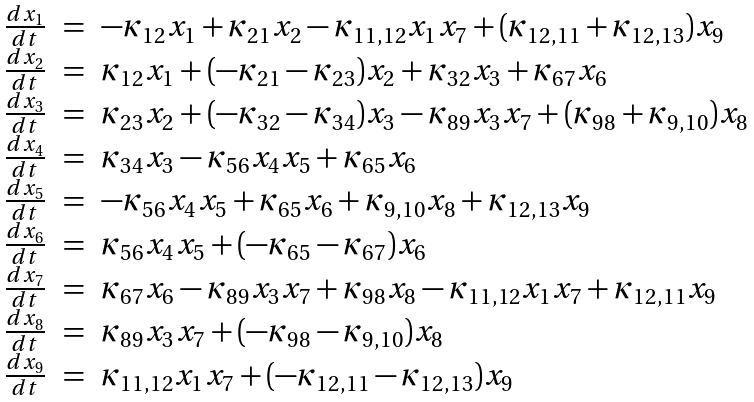Convert formula to latex. <formula><loc_0><loc_0><loc_500><loc_500>\begin{array} { c c l } \frac { d x _ { 1 } } { d t } & = & - \kappa _ { 1 2 } x _ { 1 } + \kappa _ { 2 1 } x _ { 2 } - \kappa _ { 1 1 , 1 2 } x _ { 1 } x _ { 7 } + ( \kappa _ { 1 2 , 1 1 } + \kappa _ { 1 2 , 1 3 } ) x _ { 9 } \\ \frac { d x _ { 2 } } { d t } & = & \kappa _ { 1 2 } x _ { 1 } + ( - \kappa _ { 2 1 } - \kappa _ { 2 3 } ) x _ { 2 } + \kappa _ { 3 2 } x _ { 3 } + \kappa _ { 6 7 } x _ { 6 } \\ \frac { d x _ { 3 } } { d t } & = & \kappa _ { 2 3 } x _ { 2 } + ( - \kappa _ { 3 2 } - \kappa _ { 3 4 } ) x _ { 3 } - \kappa _ { 8 9 } x _ { 3 } x _ { 7 } + ( \kappa _ { 9 8 } + \kappa _ { 9 , 1 0 } ) x _ { 8 } \\ \frac { d x _ { 4 } } { d t } & = & \kappa _ { 3 4 } x _ { 3 } - \kappa _ { 5 6 } x _ { 4 } x _ { 5 } + \kappa _ { 6 5 } x _ { 6 } \\ \frac { d x _ { 5 } } { d t } & = & - \kappa _ { 5 6 } x _ { 4 } x _ { 5 } + \kappa _ { 6 5 } x _ { 6 } + \kappa _ { 9 , 1 0 } x _ { 8 } + \kappa _ { 1 2 , 1 3 } x _ { 9 } \\ \frac { d x _ { 6 } } { d t } & = & \kappa _ { 5 6 } x _ { 4 } x _ { 5 } + ( - \kappa _ { 6 5 } - \kappa _ { 6 7 } ) x _ { 6 } \\ \frac { d x _ { 7 } } { d t } & = & \kappa _ { 6 7 } x _ { 6 } - \kappa _ { 8 9 } x _ { 3 } x _ { 7 } + \kappa _ { 9 8 } x _ { 8 } - \kappa _ { 1 1 , 1 2 } x _ { 1 } x _ { 7 } + \kappa _ { 1 2 , 1 1 } x _ { 9 } \\ \frac { d x _ { 8 } } { d t } & = & \kappa _ { 8 9 } x _ { 3 } x _ { 7 } + ( - \kappa _ { 9 8 } - \kappa _ { 9 , 1 0 } ) x _ { 8 } \\ \frac { d x _ { 9 } } { d t } & = & \kappa _ { 1 1 , 1 2 } x _ { 1 } x _ { 7 } + ( - \kappa _ { 1 2 , 1 1 } - \kappa _ { 1 2 , 1 3 } ) x _ { 9 } \end{array}</formula> 